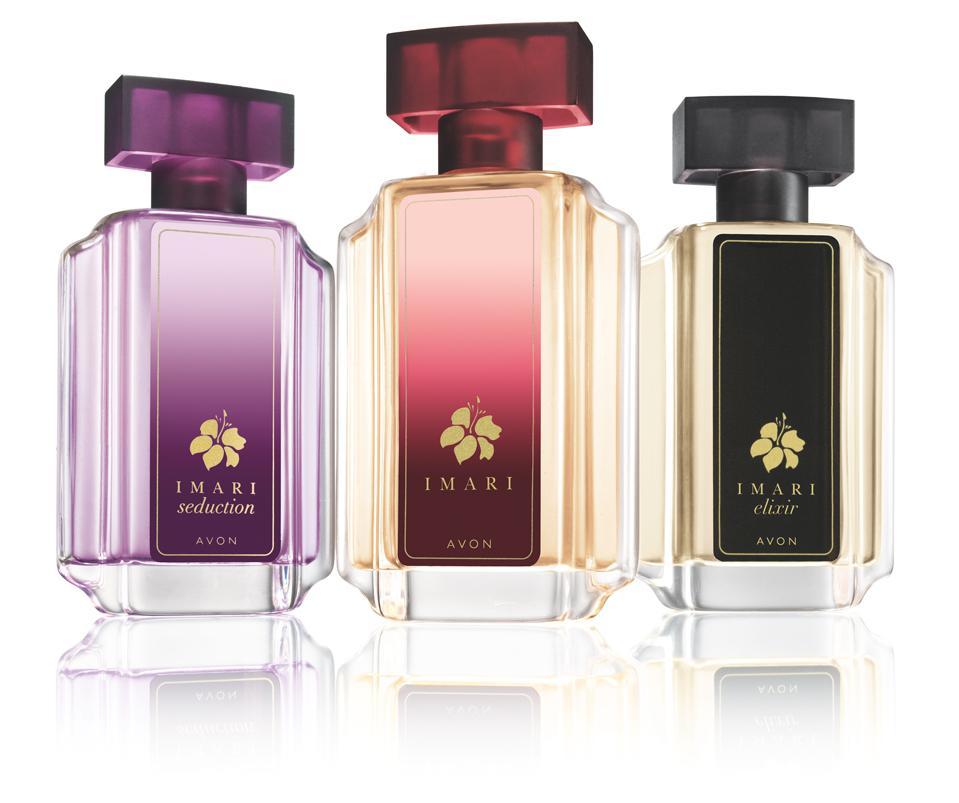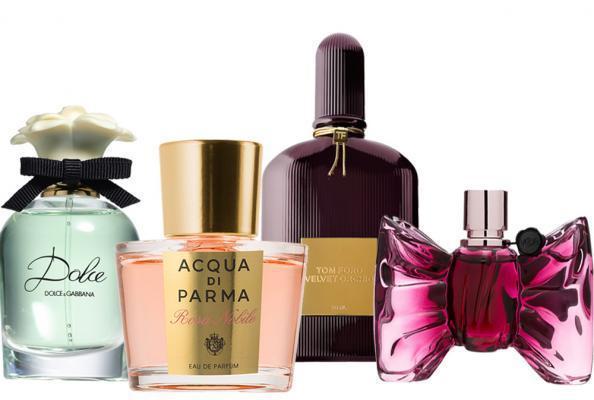The first image is the image on the left, the second image is the image on the right. Given the left and right images, does the statement "A purple perfume bottle is to the left of a black bottle and a red bottle." hold true? Answer yes or no. Yes. The first image is the image on the left, the second image is the image on the right. For the images shown, is this caption "The image on the left contains only one bottle of fragrance, and its box." true? Answer yes or no. No. 